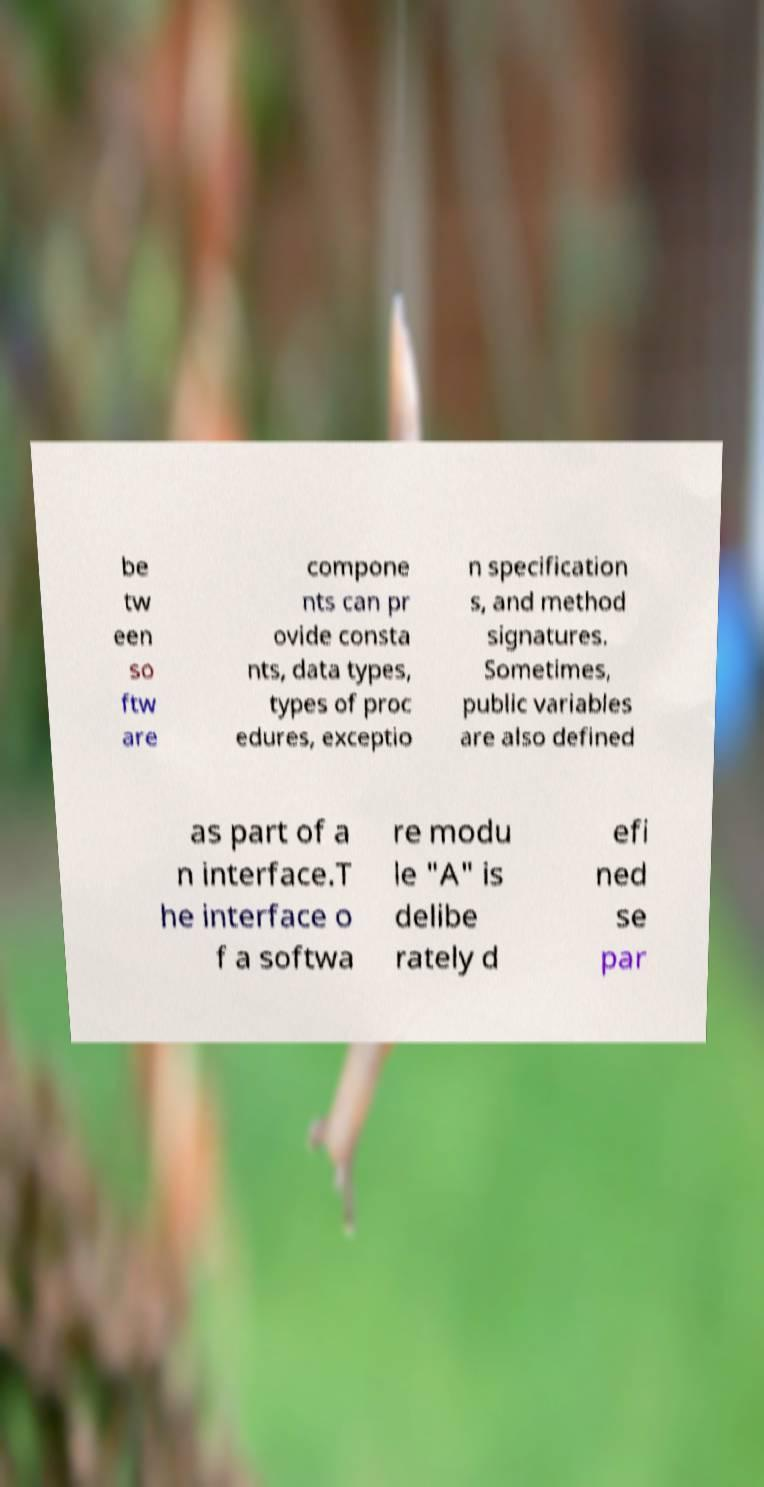Could you assist in decoding the text presented in this image and type it out clearly? be tw een so ftw are compone nts can pr ovide consta nts, data types, types of proc edures, exceptio n specification s, and method signatures. Sometimes, public variables are also defined as part of a n interface.T he interface o f a softwa re modu le "A" is delibe rately d efi ned se par 